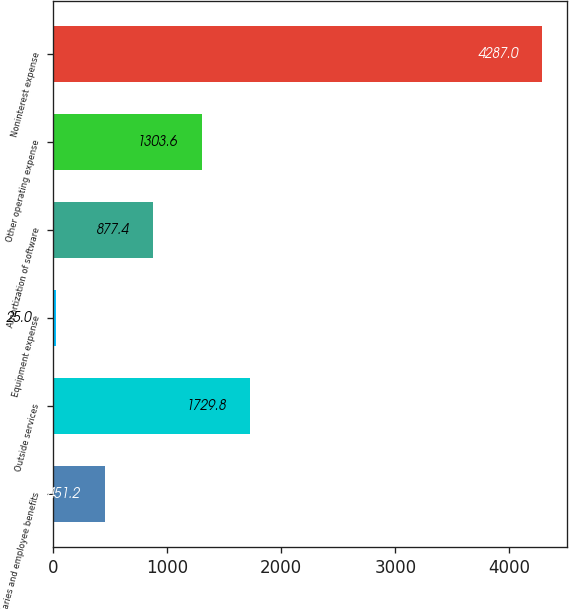<chart> <loc_0><loc_0><loc_500><loc_500><bar_chart><fcel>Salaries and employee benefits<fcel>Outside services<fcel>Equipment expense<fcel>Amortization of software<fcel>Other operating expense<fcel>Noninterest expense<nl><fcel>451.2<fcel>1729.8<fcel>25<fcel>877.4<fcel>1303.6<fcel>4287<nl></chart> 